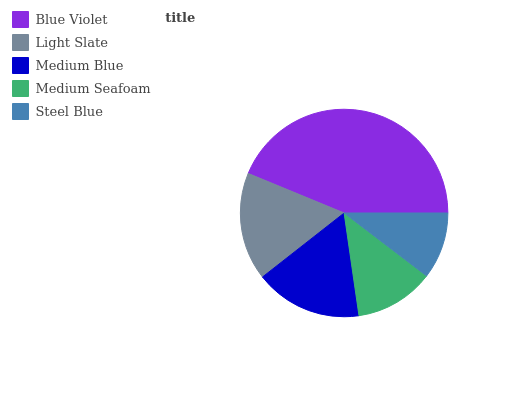Is Steel Blue the minimum?
Answer yes or no. Yes. Is Blue Violet the maximum?
Answer yes or no. Yes. Is Light Slate the minimum?
Answer yes or no. No. Is Light Slate the maximum?
Answer yes or no. No. Is Blue Violet greater than Light Slate?
Answer yes or no. Yes. Is Light Slate less than Blue Violet?
Answer yes or no. Yes. Is Light Slate greater than Blue Violet?
Answer yes or no. No. Is Blue Violet less than Light Slate?
Answer yes or no. No. Is Medium Blue the high median?
Answer yes or no. Yes. Is Medium Blue the low median?
Answer yes or no. Yes. Is Blue Violet the high median?
Answer yes or no. No. Is Light Slate the low median?
Answer yes or no. No. 